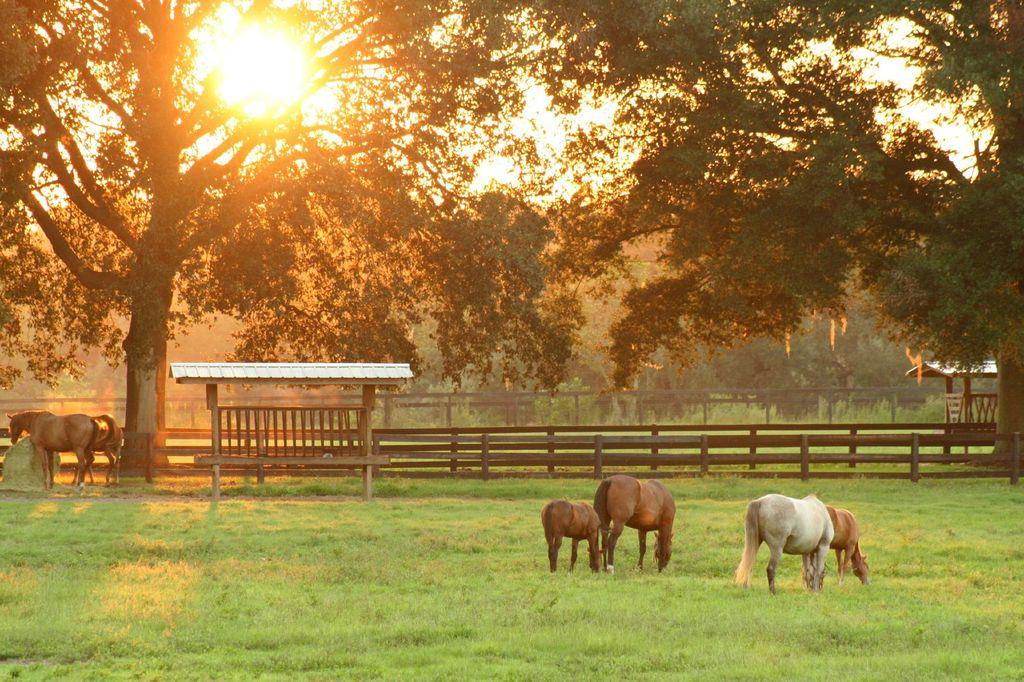What animals can be seen in the image? There are horses standing on the ground in the image. What can be seen in the background of the image? There are trees, grass, water, a fence, and the sky visible in the background of the image. Can you describe the sky in the image? The sky is visible in the background of the image, and the sun is observable in the sky. What type of list is being used by the horses in the image? There is no list present in the image; it features horses standing on the ground. 